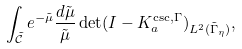<formula> <loc_0><loc_0><loc_500><loc_500>\int _ { \mathcal { \tilde { C } } } e ^ { - \tilde { \mu } } \frac { d \tilde { \mu } } { \tilde { \mu } } \det ( I - K _ { a } ^ { \csc , \Gamma } ) _ { L ^ { 2 } ( \tilde { \Gamma } _ { \eta } ) } ,</formula> 